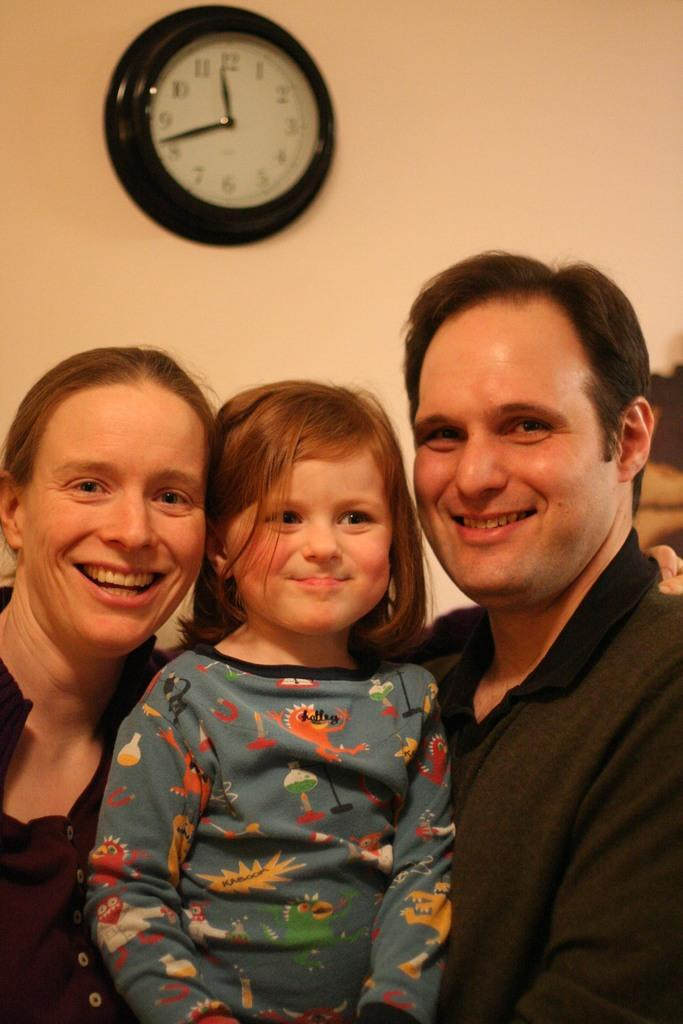<image>
Describe the image concisely. A family poses for the camera under a clock that says 20 til twelve. 